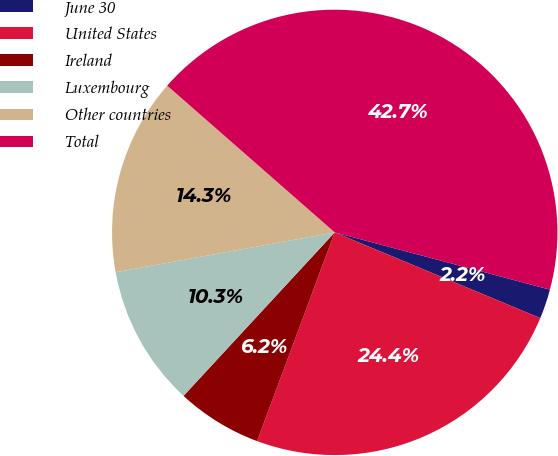Convert chart. <chart><loc_0><loc_0><loc_500><loc_500><pie_chart><fcel>June 30<fcel>United States<fcel>Ireland<fcel>Luxembourg<fcel>Other countries<fcel>Total<nl><fcel>2.15%<fcel>24.38%<fcel>6.21%<fcel>10.26%<fcel>14.31%<fcel>42.69%<nl></chart> 